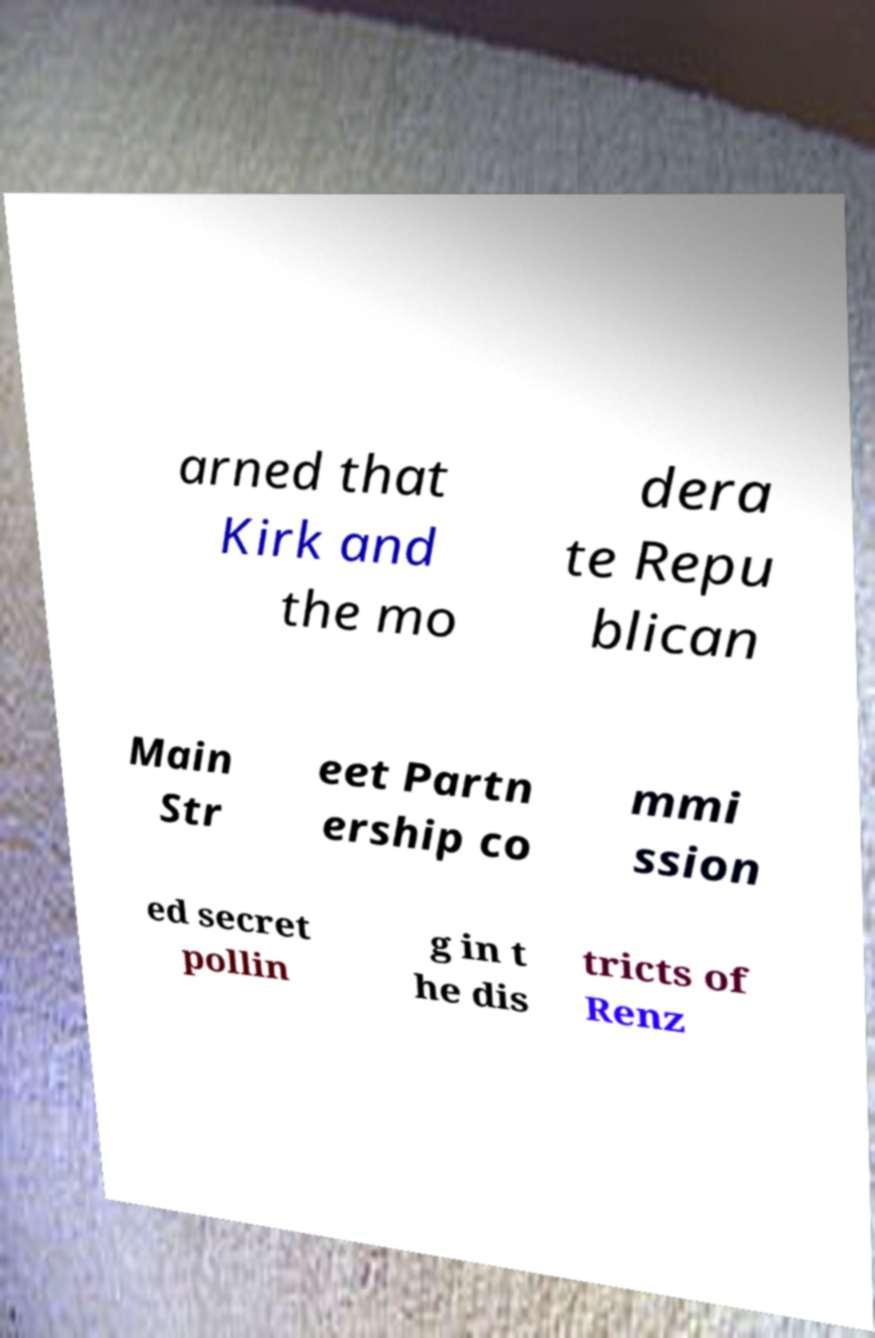Can you accurately transcribe the text from the provided image for me? arned that Kirk and the mo dera te Repu blican Main Str eet Partn ership co mmi ssion ed secret pollin g in t he dis tricts of Renz 